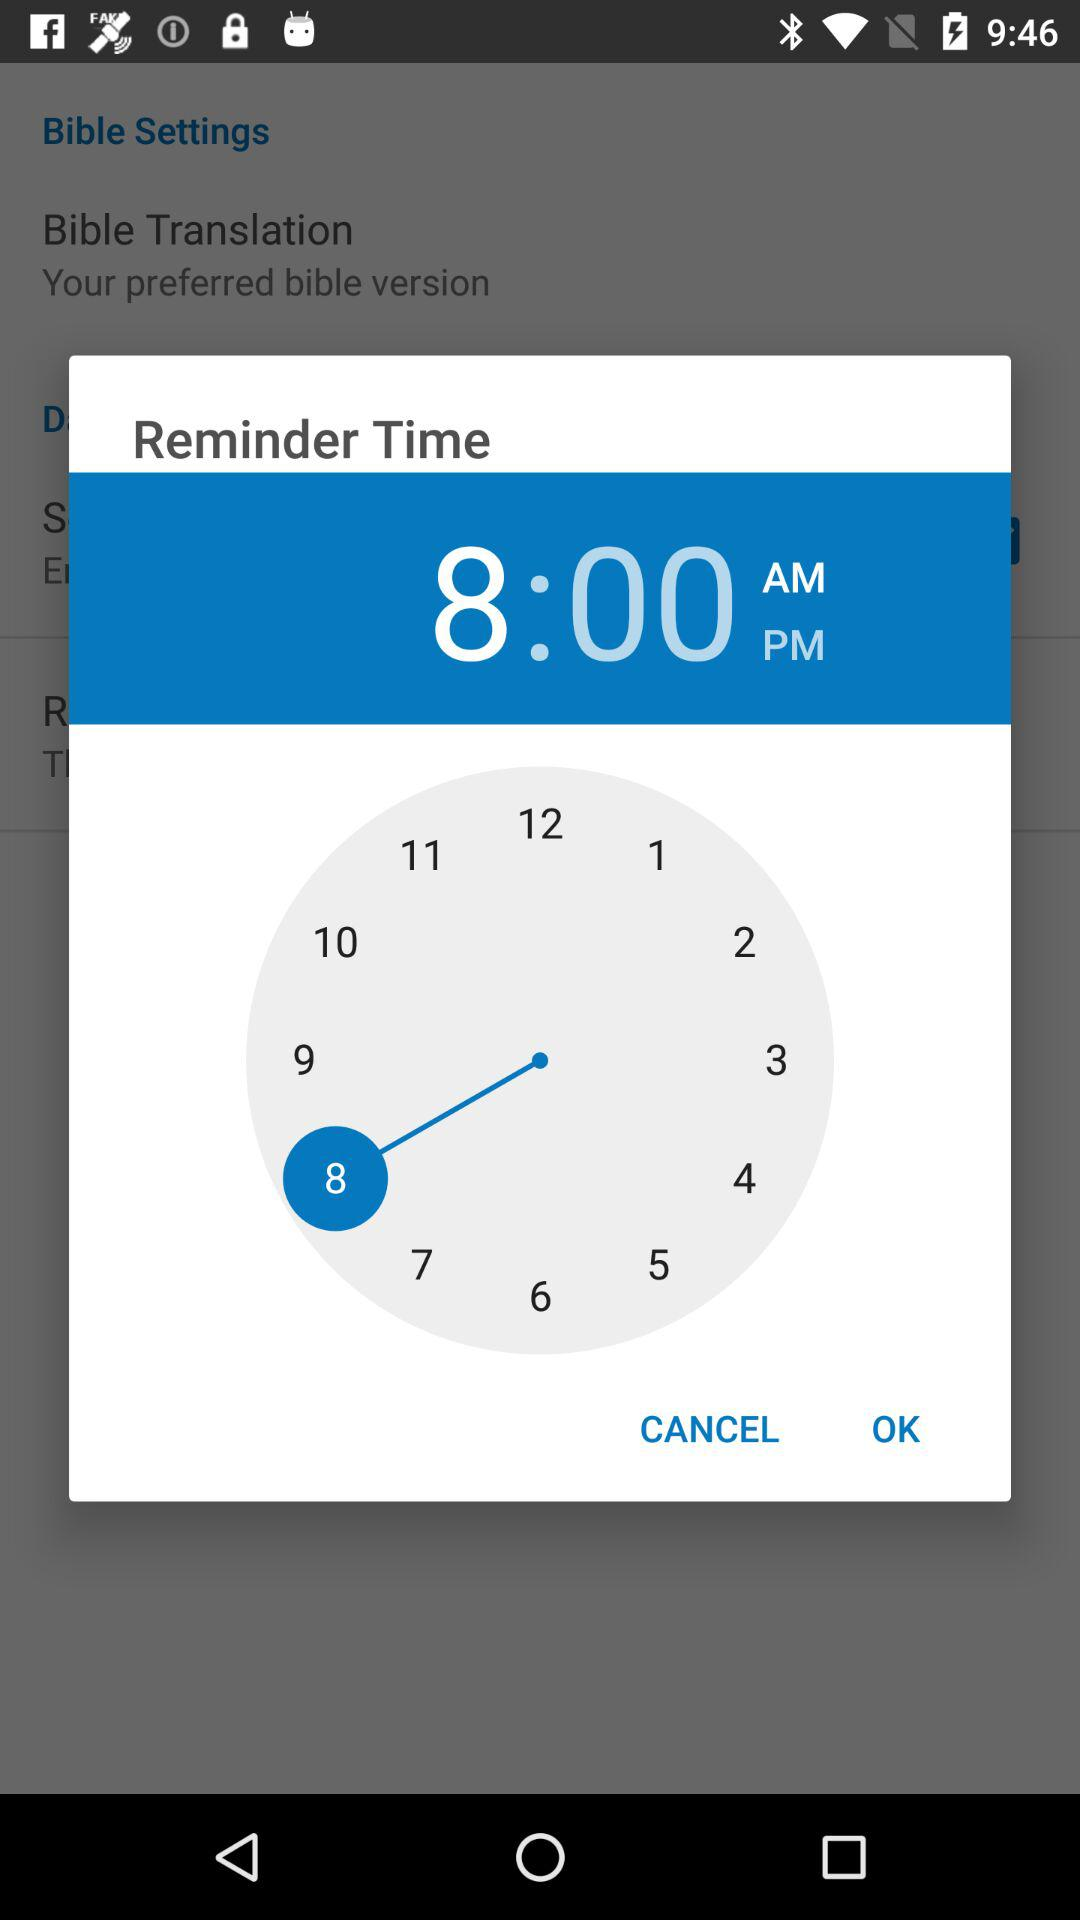What's the set reminder time? The set reminder time is 8:00 a.m. 